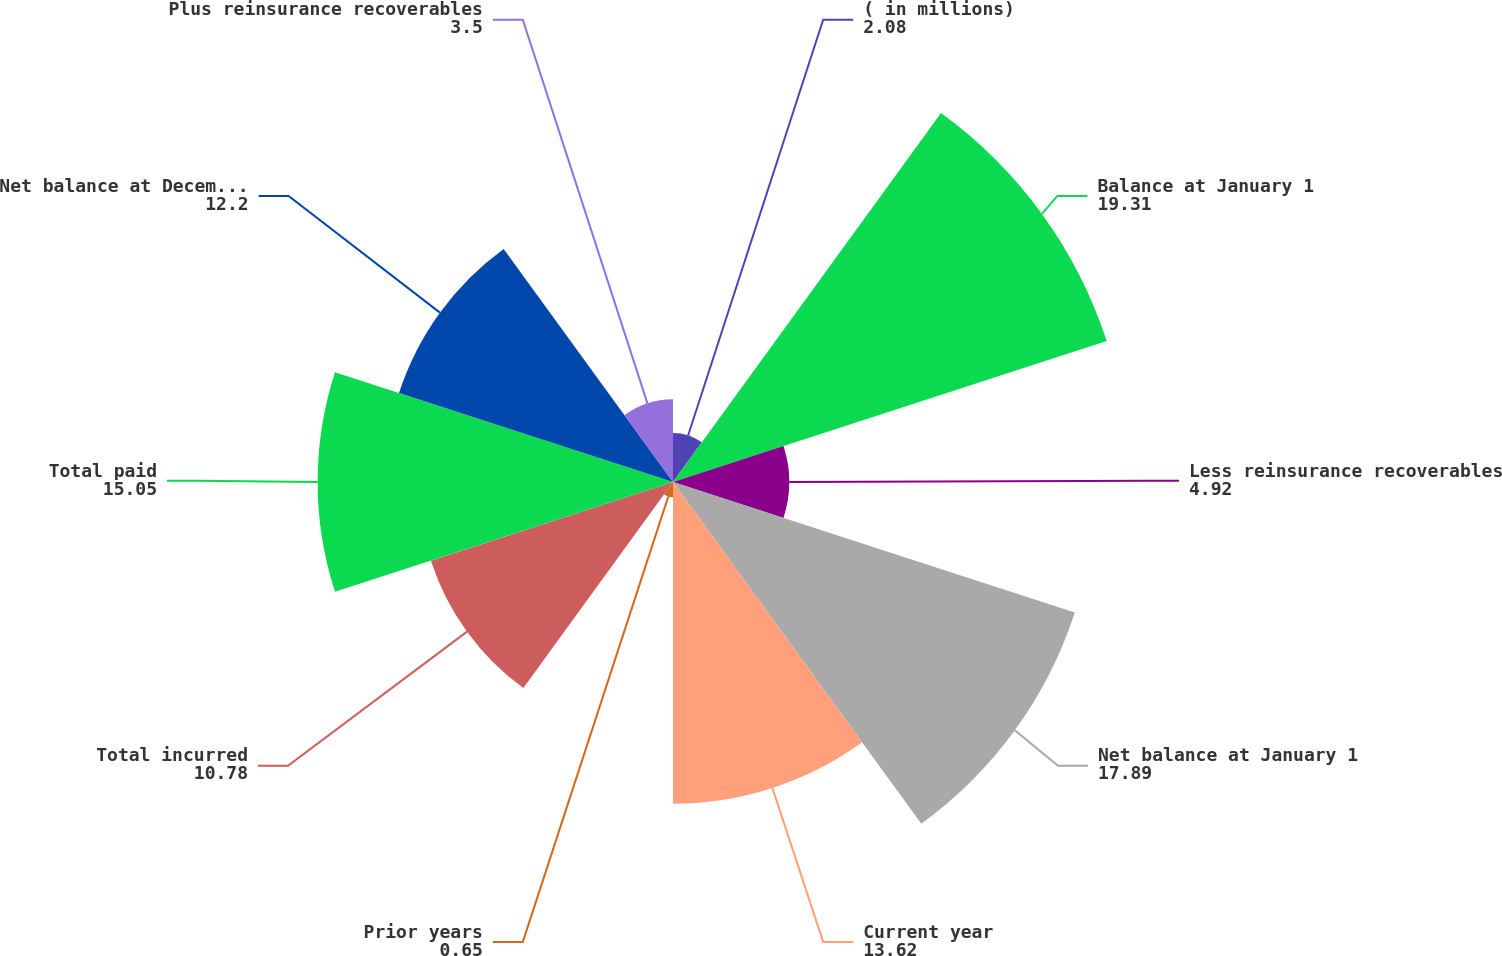Convert chart to OTSL. <chart><loc_0><loc_0><loc_500><loc_500><pie_chart><fcel>( in millions)<fcel>Balance at January 1<fcel>Less reinsurance recoverables<fcel>Net balance at January 1<fcel>Current year<fcel>Prior years<fcel>Total incurred<fcel>Total paid<fcel>Net balance at December 31<fcel>Plus reinsurance recoverables<nl><fcel>2.08%<fcel>19.31%<fcel>4.92%<fcel>17.89%<fcel>13.62%<fcel>0.65%<fcel>10.78%<fcel>15.05%<fcel>12.2%<fcel>3.5%<nl></chart> 